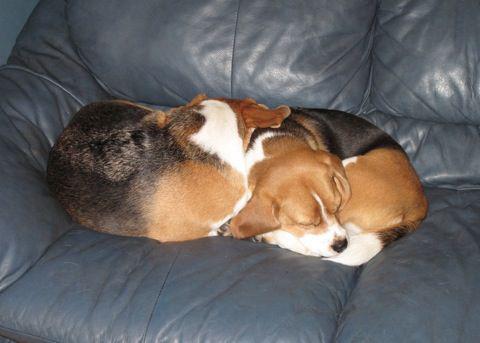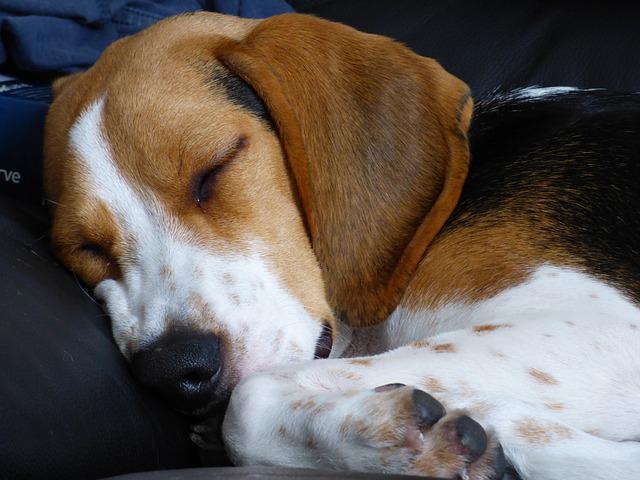The first image is the image on the left, the second image is the image on the right. Analyze the images presented: Is the assertion "At least one dog is curled up in a ball." valid? Answer yes or no. Yes. The first image is the image on the left, the second image is the image on the right. Examine the images to the left and right. Is the description "The dogs are lying in the same direction." accurate? Answer yes or no. No. 